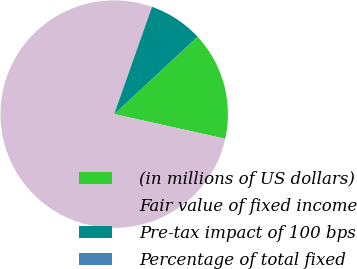Convert chart. <chart><loc_0><loc_0><loc_500><loc_500><pie_chart><fcel>(in millions of US dollars)<fcel>Fair value of fixed income<fcel>Pre-tax impact of 100 bps<fcel>Percentage of total fixed<nl><fcel>15.39%<fcel>76.91%<fcel>7.7%<fcel>0.01%<nl></chart> 